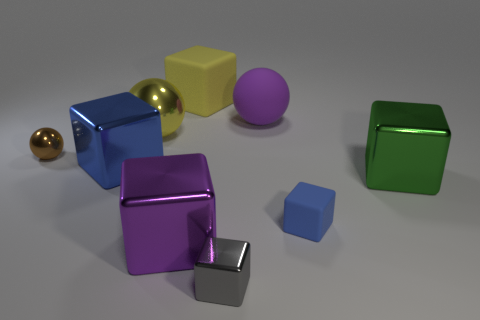What is the color of the shiny block behind the big shiny block on the right side of the big purple metallic block?
Keep it short and to the point. Blue. How many big metal things are there?
Make the answer very short. 4. Does the big rubber cube have the same color as the large shiny sphere?
Provide a succinct answer. Yes. Are there fewer blue metal cubes right of the blue shiny object than purple cubes to the left of the purple ball?
Your response must be concise. Yes. What color is the tiny matte thing?
Offer a terse response. Blue. How many shiny balls are the same color as the small metal block?
Your answer should be compact. 0. Are there any things to the left of the purple block?
Offer a terse response. Yes. Are there the same number of small spheres to the right of the small brown sphere and large cubes behind the yellow shiny sphere?
Ensure brevity in your answer.  No. Is the size of the blue block in front of the large green block the same as the green block to the right of the large yellow block?
Provide a succinct answer. No. What shape is the large object that is to the right of the blue block that is in front of the metal cube on the right side of the small blue rubber cube?
Provide a succinct answer. Cube. 